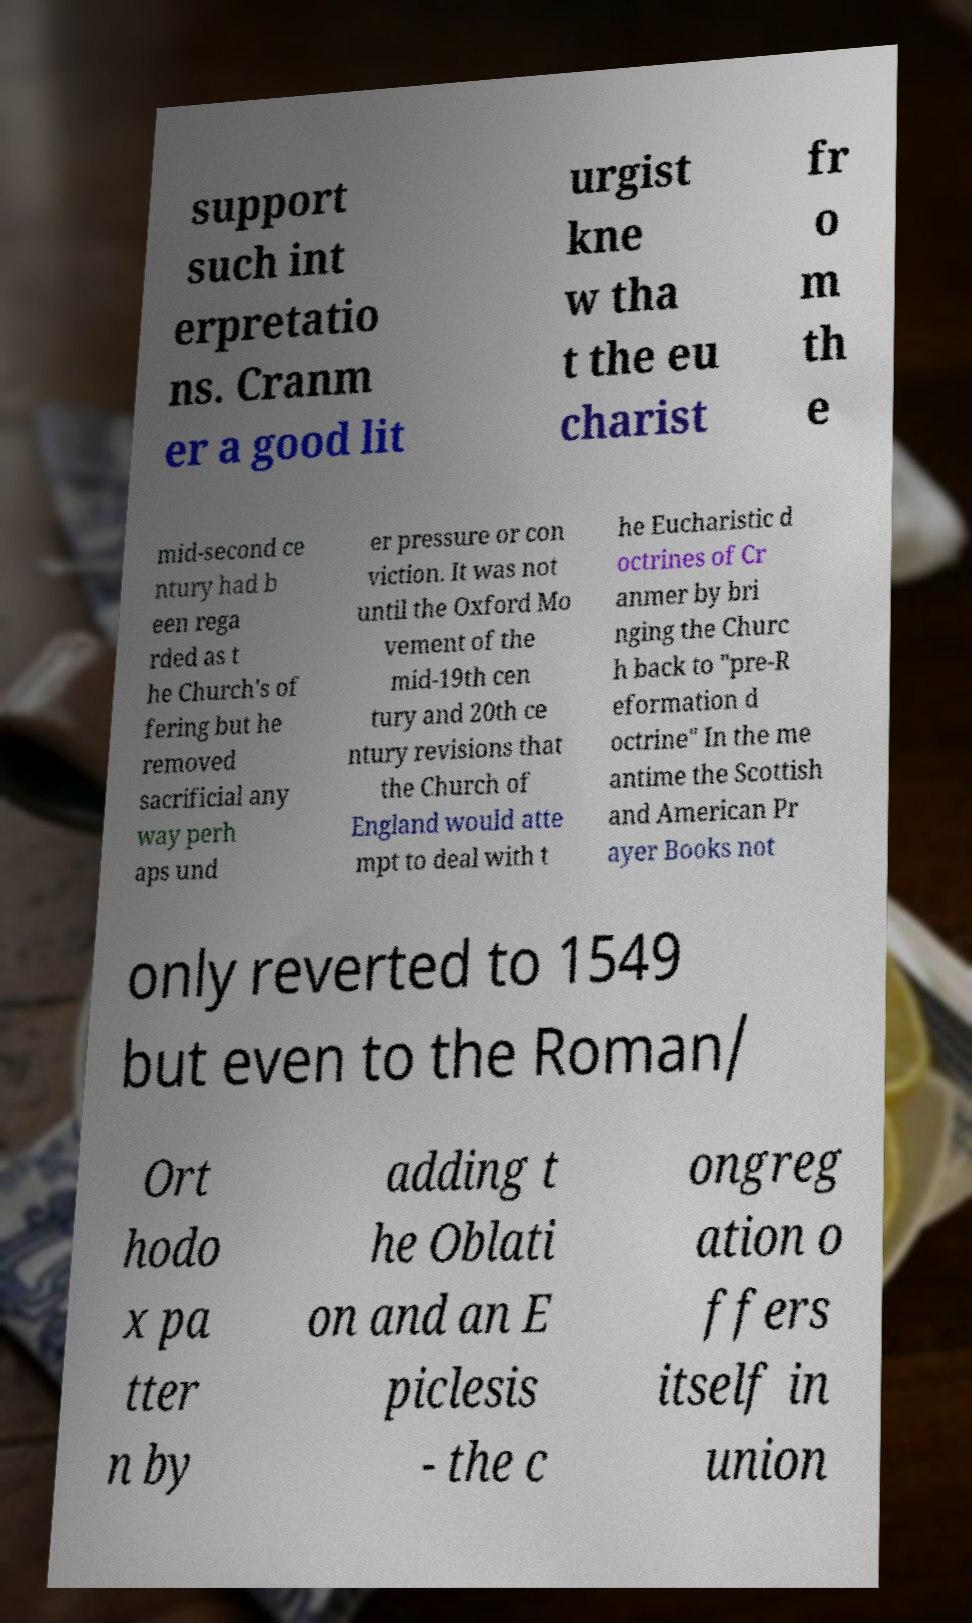Could you extract and type out the text from this image? support such int erpretatio ns. Cranm er a good lit urgist kne w tha t the eu charist fr o m th e mid-second ce ntury had b een rega rded as t he Church's of fering but he removed sacrificial any way perh aps und er pressure or con viction. It was not until the Oxford Mo vement of the mid-19th cen tury and 20th ce ntury revisions that the Church of England would atte mpt to deal with t he Eucharistic d octrines of Cr anmer by bri nging the Churc h back to "pre-R eformation d octrine" In the me antime the Scottish and American Pr ayer Books not only reverted to 1549 but even to the Roman/ Ort hodo x pa tter n by adding t he Oblati on and an E piclesis - the c ongreg ation o ffers itself in union 